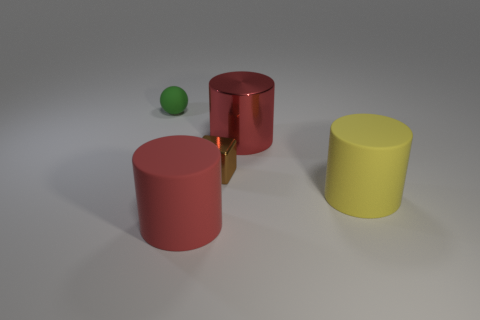There is a rubber cylinder that is the same size as the red rubber object; what is its color?
Offer a terse response. Yellow. Do the big yellow thing and the red thing in front of the brown object have the same shape?
Give a very brief answer. Yes. There is a big red cylinder behind the rubber cylinder that is to the left of the rubber cylinder that is behind the red rubber object; what is its material?
Provide a short and direct response. Metal. How many big objects are shiny cylinders or green matte cubes?
Ensure brevity in your answer.  1. How many other objects are the same size as the shiny cube?
Keep it short and to the point. 1. Is the shape of the large red thing in front of the brown metal block the same as  the small green rubber thing?
Offer a very short reply. No. There is another large shiny thing that is the same shape as the big yellow object; what color is it?
Ensure brevity in your answer.  Red. Is there anything else that is the same shape as the tiny green object?
Make the answer very short. No. Are there an equal number of green balls in front of the green matte ball and green shiny cylinders?
Provide a succinct answer. Yes. How many objects are behind the large yellow object and in front of the large metallic object?
Give a very brief answer. 1. 